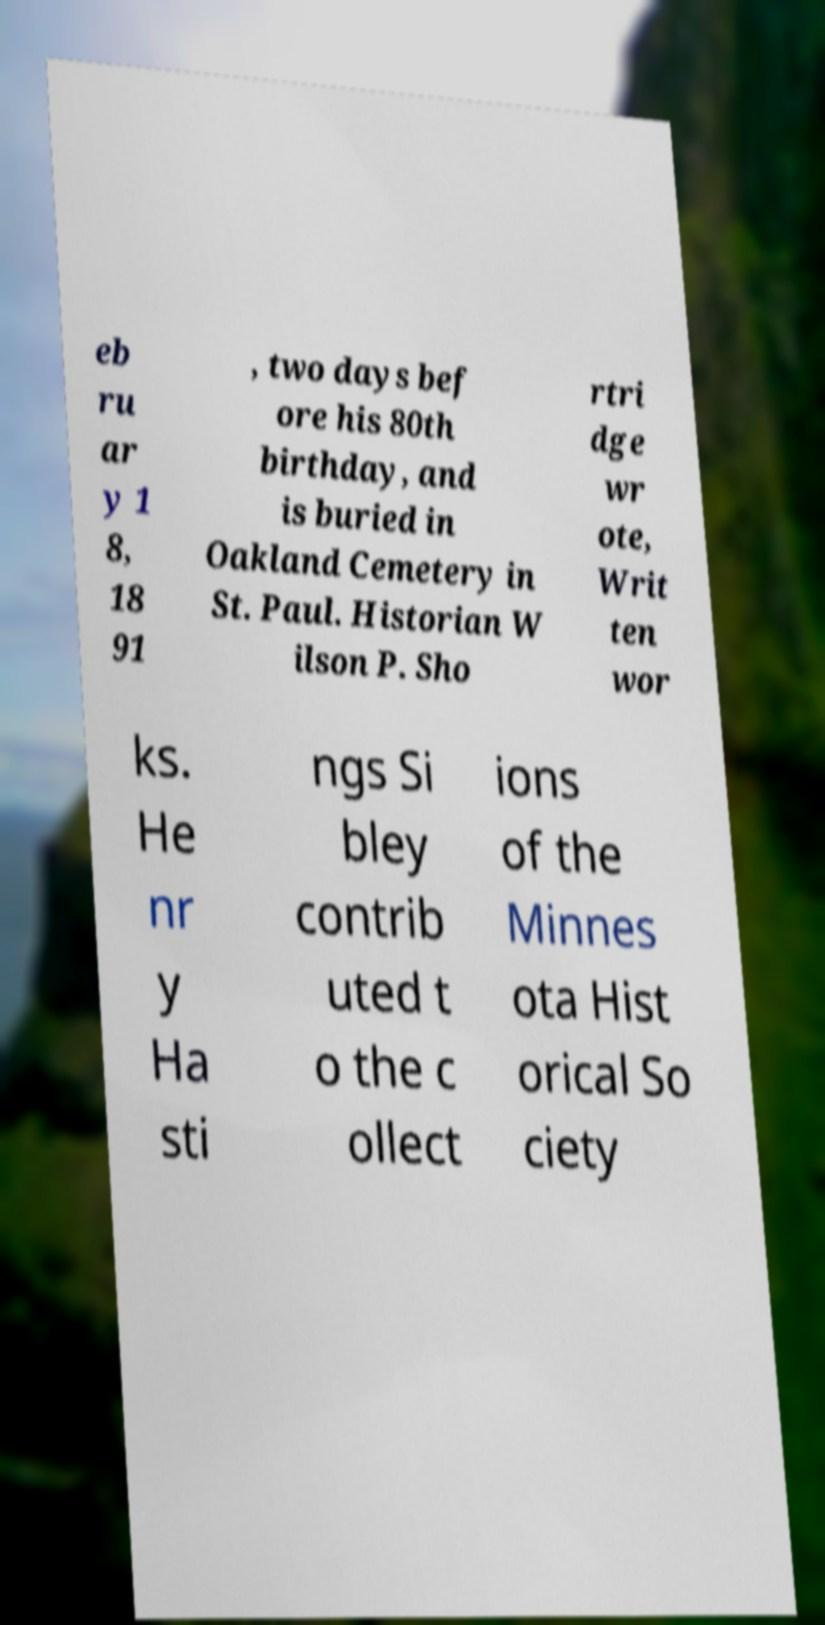What messages or text are displayed in this image? I need them in a readable, typed format. eb ru ar y 1 8, 18 91 , two days bef ore his 80th birthday, and is buried in Oakland Cemetery in St. Paul. Historian W ilson P. Sho rtri dge wr ote, Writ ten wor ks. He nr y Ha sti ngs Si bley contrib uted t o the c ollect ions of the Minnes ota Hist orical So ciety 